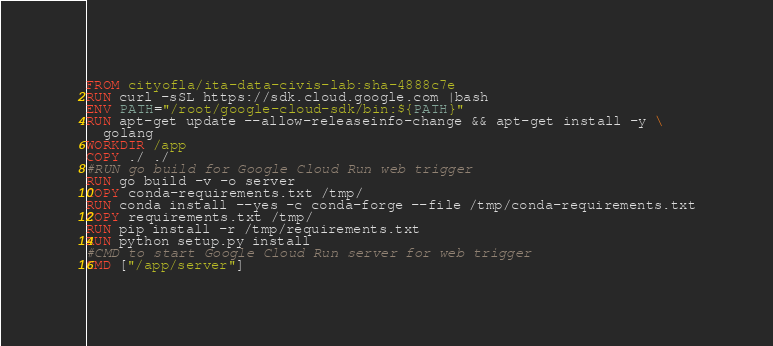Convert code to text. <code><loc_0><loc_0><loc_500><loc_500><_Dockerfile_>FROM cityofla/ita-data-civis-lab:sha-4888c7e  
RUN curl -sSL https://sdk.cloud.google.com |bash
ENV PATH="/root/google-cloud-sdk/bin:${PATH}"
RUN apt-get update --allow-releaseinfo-change && apt-get install -y \
  golang
WORKDIR /app
COPY ./ ./
#RUN go build for Google Cloud Run web trigger
RUN go build -v -o server
COPY conda-requirements.txt /tmp/
RUN conda install --yes -c conda-forge --file /tmp/conda-requirements.txt
COPY requirements.txt /tmp/
RUN pip install -r /tmp/requirements.txt
RUN python setup.py install
#CMD to start Google Cloud Run server for web trigger
CMD ["/app/server"]
</code> 